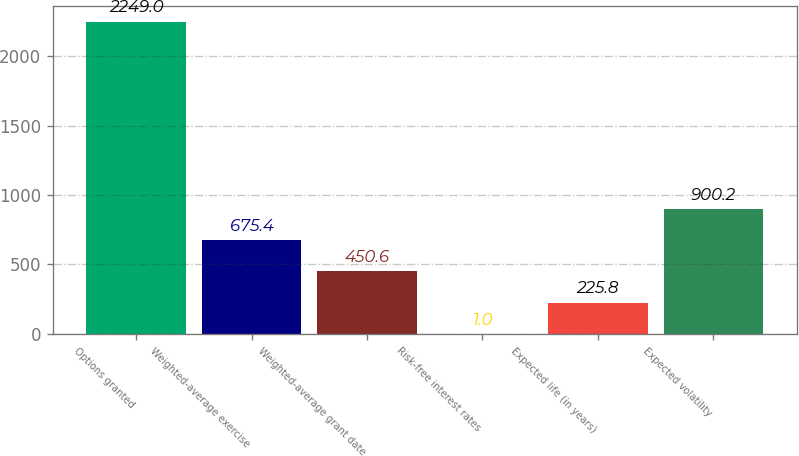<chart> <loc_0><loc_0><loc_500><loc_500><bar_chart><fcel>Options granted<fcel>Weighted-average exercise<fcel>Weighted-average grant date<fcel>Risk-free interest rates<fcel>Expected life (in years)<fcel>Expected volatility<nl><fcel>2249<fcel>675.4<fcel>450.6<fcel>1<fcel>225.8<fcel>900.2<nl></chart> 